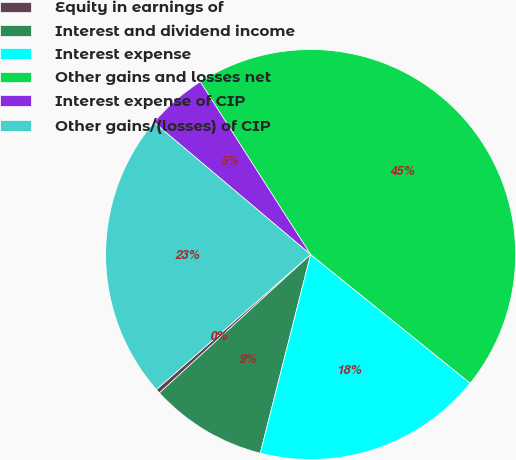Convert chart. <chart><loc_0><loc_0><loc_500><loc_500><pie_chart><fcel>Equity in earnings of<fcel>Interest and dividend income<fcel>Interest expense<fcel>Other gains and losses net<fcel>Interest expense of CIP<fcel>Other gains/(losses) of CIP<nl><fcel>0.35%<fcel>9.25%<fcel>18.15%<fcel>44.85%<fcel>4.8%<fcel>22.6%<nl></chart> 